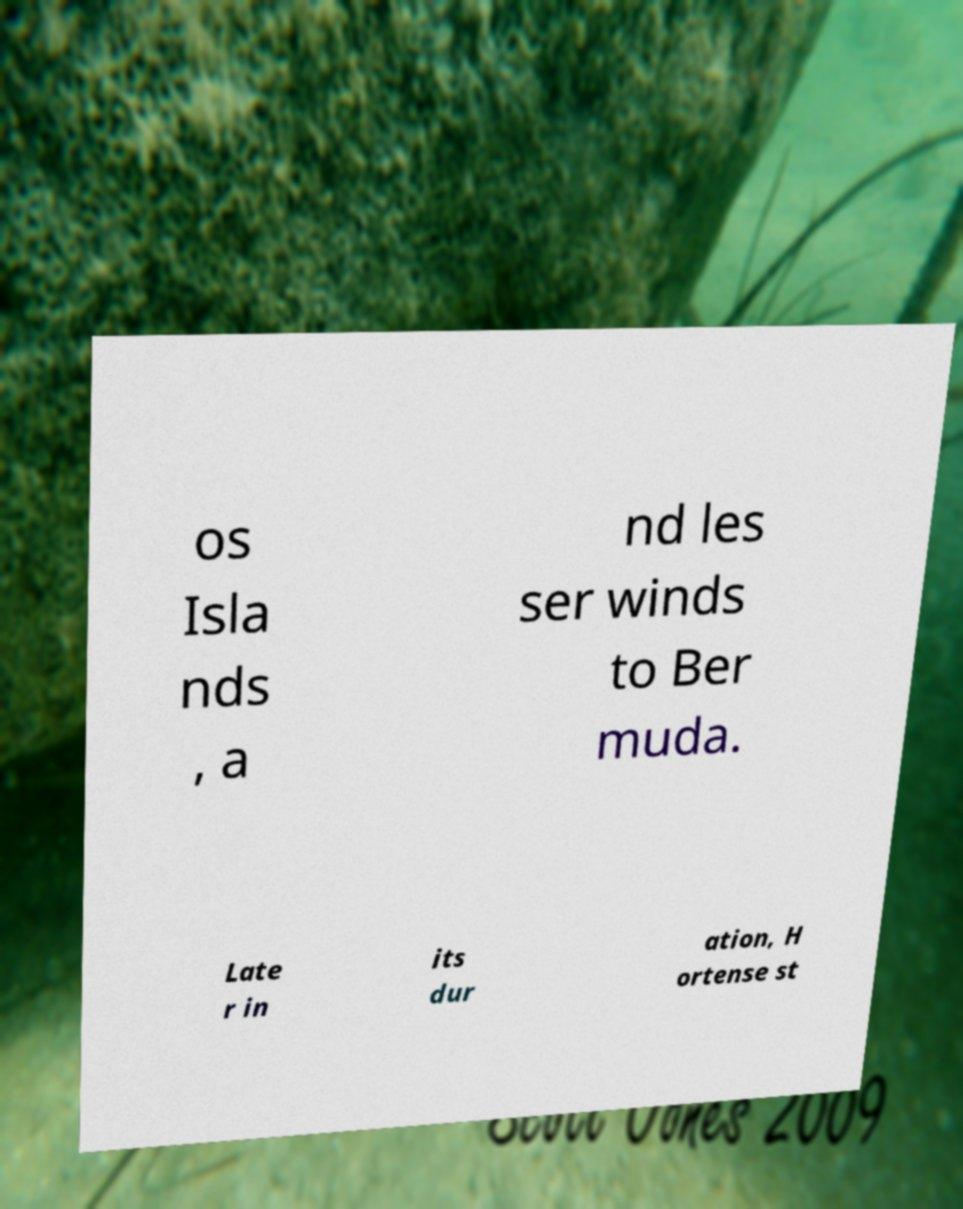Can you accurately transcribe the text from the provided image for me? os Isla nds , a nd les ser winds to Ber muda. Late r in its dur ation, H ortense st 